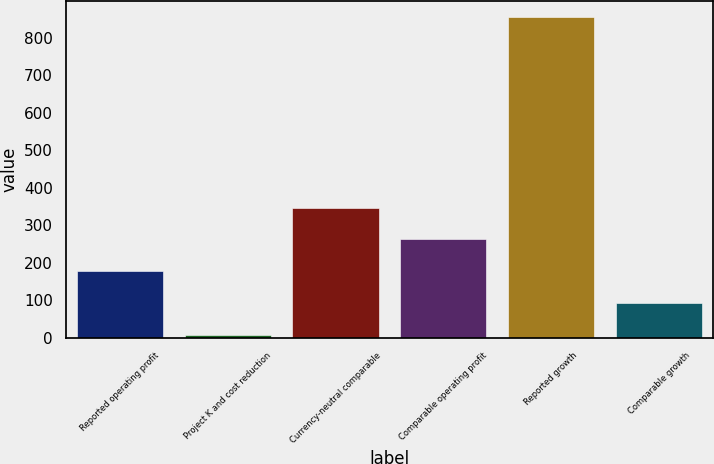<chart> <loc_0><loc_0><loc_500><loc_500><bar_chart><fcel>Reported operating profit<fcel>Project K and cost reduction<fcel>Currency-neutral comparable<fcel>Comparable operating profit<fcel>Reported growth<fcel>Comparable growth<nl><fcel>177.44<fcel>8<fcel>346.88<fcel>262.16<fcel>855.2<fcel>92.72<nl></chart> 